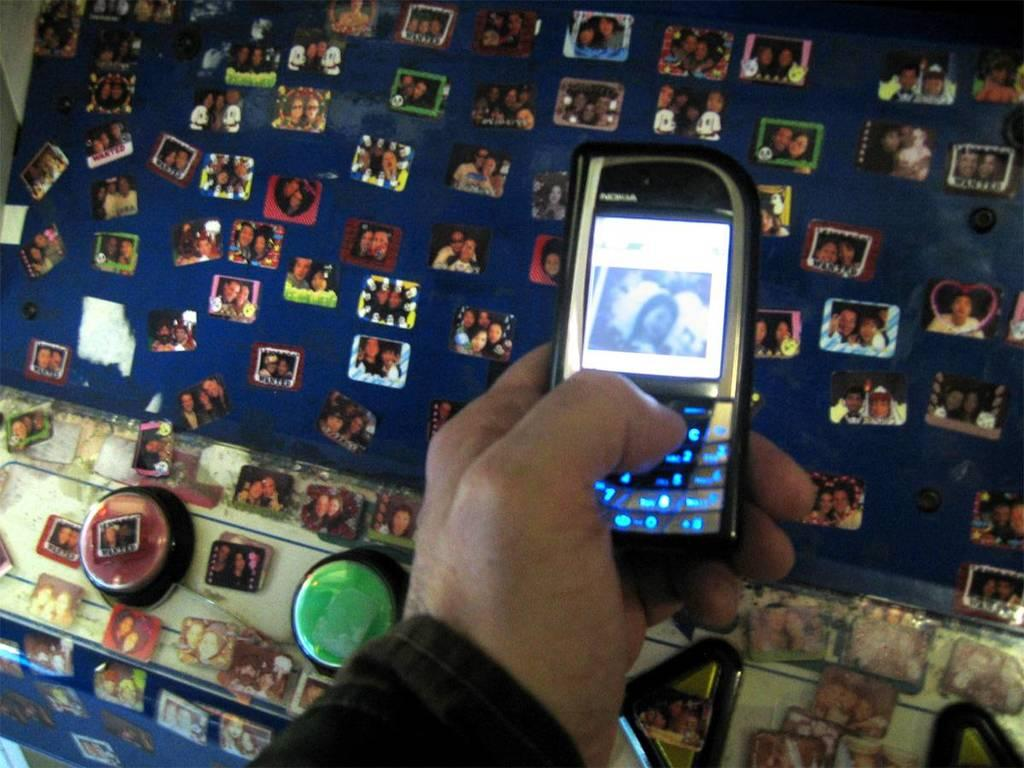<image>
Provide a brief description of the given image. the word Nokia is on the light screen 